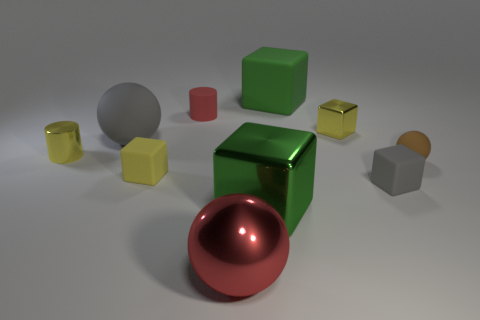Is there a big green object in front of the small yellow thing that is left of the tiny yellow rubber object?
Provide a succinct answer. Yes. Are there any other things that have the same shape as the red metal thing?
Offer a terse response. Yes. Does the green matte object have the same size as the gray rubber sphere?
Provide a succinct answer. Yes. What is the material of the red object that is behind the tiny shiny object in front of the big ball that is behind the large red metallic object?
Your response must be concise. Rubber. Are there an equal number of yellow matte objects that are right of the matte cylinder and brown spheres?
Offer a very short reply. No. Are there any other things that have the same size as the brown matte thing?
Provide a succinct answer. Yes. What number of objects are small red metallic cubes or large gray balls?
Give a very brief answer. 1. The red thing that is the same material as the tiny gray cube is what shape?
Provide a succinct answer. Cylinder. What size is the green cube that is in front of the big green object that is behind the tiny metallic cube?
Provide a succinct answer. Large. What number of tiny objects are either yellow rubber blocks or matte cylinders?
Provide a succinct answer. 2. 